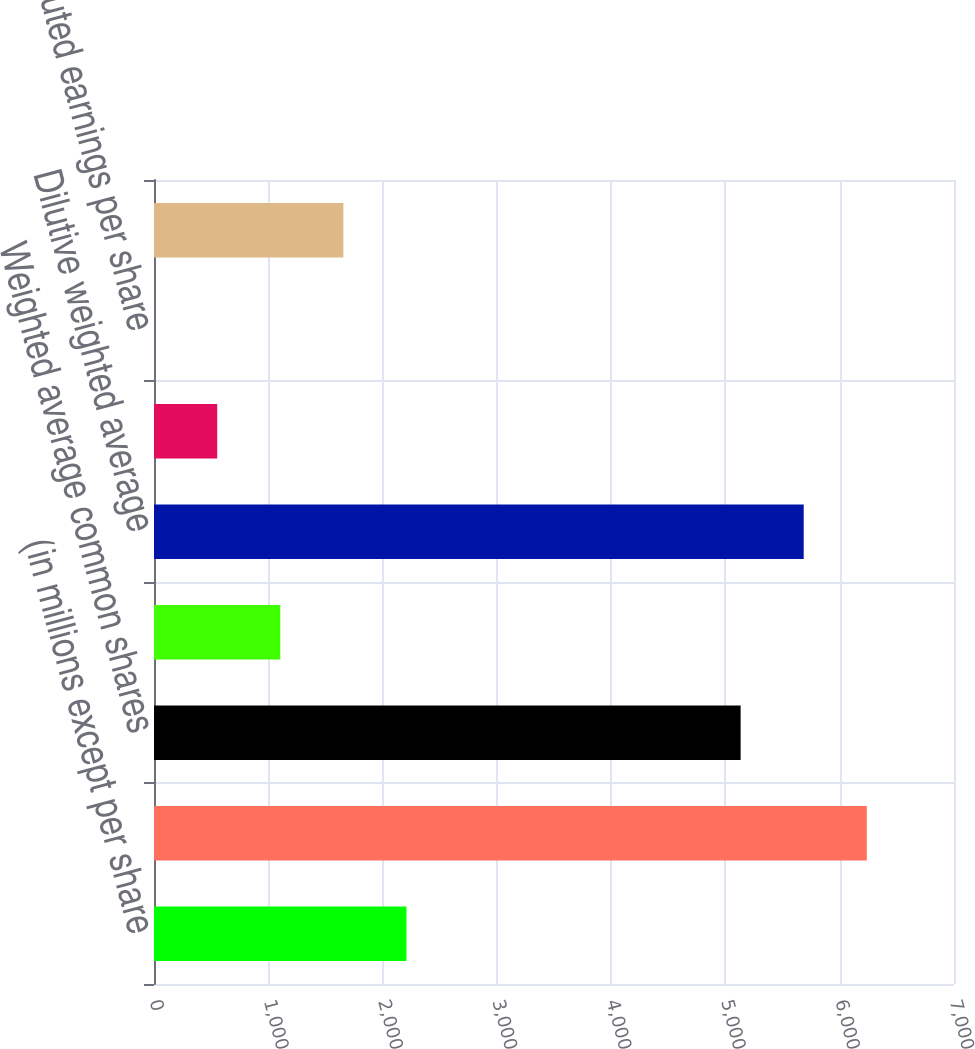<chart> <loc_0><loc_0><loc_500><loc_500><bar_chart><fcel>(in millions except per share<fcel>Net income<fcel>Weighted average common shares<fcel>Dilutive effect of employee<fcel>Dilutive weighted average<fcel>Basic earnings per share<fcel>Diluted earnings per share<fcel>Shares subject to<nl><fcel>2209.02<fcel>6236.98<fcel>5133<fcel>1105.04<fcel>5684.99<fcel>553.05<fcel>1.06<fcel>1657.03<nl></chart> 